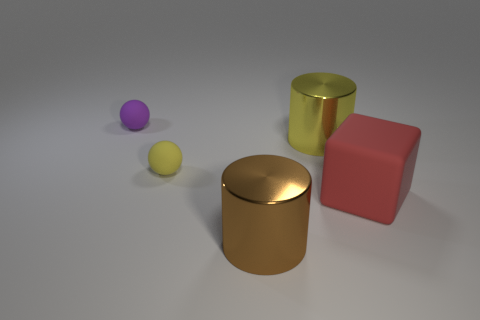Add 2 small red matte spheres. How many objects exist? 7 Subtract all cubes. How many objects are left? 4 Add 1 metallic cylinders. How many metallic cylinders are left? 3 Add 1 large red rubber objects. How many large red rubber objects exist? 2 Subtract 0 green spheres. How many objects are left? 5 Subtract all yellow balls. Subtract all matte objects. How many objects are left? 1 